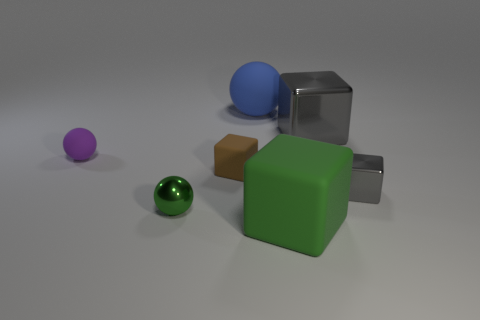Add 2 brown things. How many objects exist? 9 Subtract all cubes. How many objects are left? 3 Subtract 0 yellow balls. How many objects are left? 7 Subtract all blue balls. Subtract all big green rubber blocks. How many objects are left? 5 Add 6 blue objects. How many blue objects are left? 7 Add 4 tiny objects. How many tiny objects exist? 8 